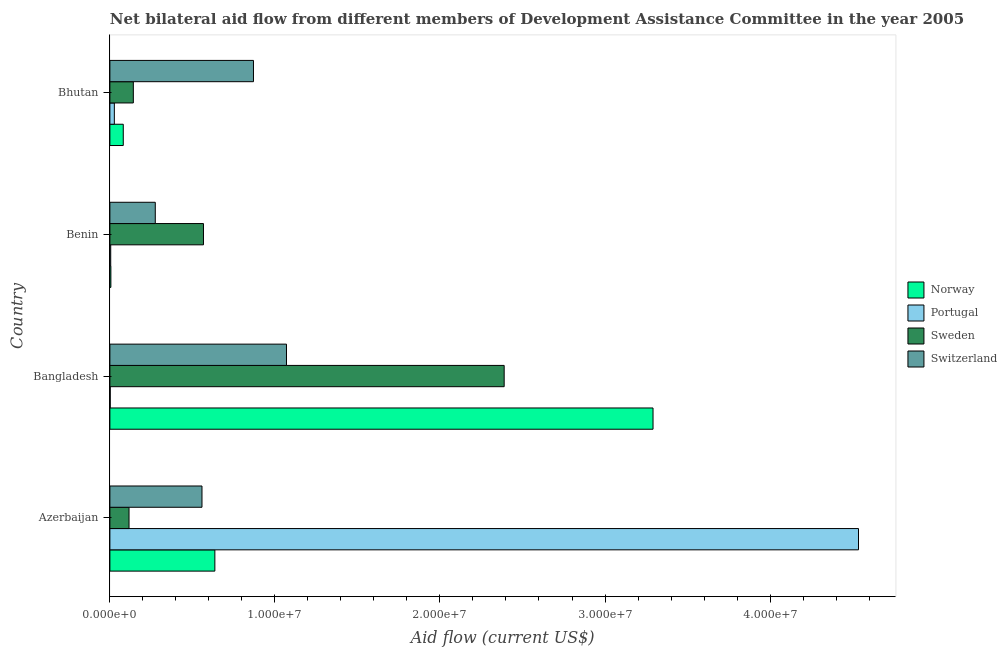How many different coloured bars are there?
Keep it short and to the point. 4. Are the number of bars on each tick of the Y-axis equal?
Make the answer very short. Yes. What is the label of the 4th group of bars from the top?
Give a very brief answer. Azerbaijan. In how many cases, is the number of bars for a given country not equal to the number of legend labels?
Provide a succinct answer. 0. What is the amount of aid given by portugal in Benin?
Provide a succinct answer. 5.00e+04. Across all countries, what is the maximum amount of aid given by norway?
Ensure brevity in your answer.  3.29e+07. Across all countries, what is the minimum amount of aid given by portugal?
Offer a very short reply. 2.00e+04. In which country was the amount of aid given by portugal maximum?
Make the answer very short. Azerbaijan. In which country was the amount of aid given by switzerland minimum?
Provide a succinct answer. Benin. What is the total amount of aid given by switzerland in the graph?
Provide a succinct answer. 2.77e+07. What is the difference between the amount of aid given by portugal in Azerbaijan and that in Bangladesh?
Your answer should be compact. 4.53e+07. What is the difference between the amount of aid given by sweden in Bangladesh and the amount of aid given by portugal in Azerbaijan?
Provide a succinct answer. -2.15e+07. What is the average amount of aid given by portugal per country?
Offer a very short reply. 1.14e+07. What is the difference between the amount of aid given by portugal and amount of aid given by switzerland in Benin?
Make the answer very short. -2.70e+06. In how many countries, is the amount of aid given by sweden greater than 42000000 US$?
Give a very brief answer. 0. What is the ratio of the amount of aid given by switzerland in Azerbaijan to that in Benin?
Your answer should be compact. 2.03. Is the difference between the amount of aid given by portugal in Azerbaijan and Benin greater than the difference between the amount of aid given by norway in Azerbaijan and Benin?
Your answer should be very brief. Yes. What is the difference between the highest and the second highest amount of aid given by switzerland?
Give a very brief answer. 2.00e+06. What is the difference between the highest and the lowest amount of aid given by switzerland?
Keep it short and to the point. 7.95e+06. Is the sum of the amount of aid given by portugal in Azerbaijan and Benin greater than the maximum amount of aid given by switzerland across all countries?
Keep it short and to the point. Yes. What does the 1st bar from the top in Bhutan represents?
Your answer should be compact. Switzerland. Is it the case that in every country, the sum of the amount of aid given by norway and amount of aid given by portugal is greater than the amount of aid given by sweden?
Your answer should be compact. No. How many bars are there?
Provide a short and direct response. 16. Are all the bars in the graph horizontal?
Your response must be concise. Yes. Are the values on the major ticks of X-axis written in scientific E-notation?
Make the answer very short. Yes. Does the graph contain any zero values?
Provide a succinct answer. No. Where does the legend appear in the graph?
Offer a terse response. Center right. How are the legend labels stacked?
Offer a terse response. Vertical. What is the title of the graph?
Your answer should be very brief. Net bilateral aid flow from different members of Development Assistance Committee in the year 2005. What is the label or title of the Y-axis?
Provide a succinct answer. Country. What is the Aid flow (current US$) of Norway in Azerbaijan?
Provide a succinct answer. 6.36e+06. What is the Aid flow (current US$) of Portugal in Azerbaijan?
Your answer should be compact. 4.54e+07. What is the Aid flow (current US$) of Sweden in Azerbaijan?
Ensure brevity in your answer.  1.16e+06. What is the Aid flow (current US$) of Switzerland in Azerbaijan?
Ensure brevity in your answer.  5.58e+06. What is the Aid flow (current US$) of Norway in Bangladesh?
Your response must be concise. 3.29e+07. What is the Aid flow (current US$) of Portugal in Bangladesh?
Provide a short and direct response. 2.00e+04. What is the Aid flow (current US$) in Sweden in Bangladesh?
Keep it short and to the point. 2.39e+07. What is the Aid flow (current US$) in Switzerland in Bangladesh?
Make the answer very short. 1.07e+07. What is the Aid flow (current US$) of Portugal in Benin?
Provide a succinct answer. 5.00e+04. What is the Aid flow (current US$) in Sweden in Benin?
Ensure brevity in your answer.  5.67e+06. What is the Aid flow (current US$) of Switzerland in Benin?
Ensure brevity in your answer.  2.75e+06. What is the Aid flow (current US$) of Norway in Bhutan?
Provide a short and direct response. 8.10e+05. What is the Aid flow (current US$) in Sweden in Bhutan?
Your answer should be very brief. 1.42e+06. What is the Aid flow (current US$) of Switzerland in Bhutan?
Your response must be concise. 8.70e+06. Across all countries, what is the maximum Aid flow (current US$) in Norway?
Give a very brief answer. 3.29e+07. Across all countries, what is the maximum Aid flow (current US$) of Portugal?
Offer a very short reply. 4.54e+07. Across all countries, what is the maximum Aid flow (current US$) of Sweden?
Offer a terse response. 2.39e+07. Across all countries, what is the maximum Aid flow (current US$) in Switzerland?
Keep it short and to the point. 1.07e+07. Across all countries, what is the minimum Aid flow (current US$) in Sweden?
Your answer should be very brief. 1.16e+06. Across all countries, what is the minimum Aid flow (current US$) of Switzerland?
Offer a very short reply. 2.75e+06. What is the total Aid flow (current US$) in Norway in the graph?
Provide a short and direct response. 4.01e+07. What is the total Aid flow (current US$) of Portugal in the graph?
Ensure brevity in your answer.  4.57e+07. What is the total Aid flow (current US$) of Sweden in the graph?
Your answer should be very brief. 3.21e+07. What is the total Aid flow (current US$) in Switzerland in the graph?
Ensure brevity in your answer.  2.77e+07. What is the difference between the Aid flow (current US$) of Norway in Azerbaijan and that in Bangladesh?
Your answer should be compact. -2.66e+07. What is the difference between the Aid flow (current US$) in Portugal in Azerbaijan and that in Bangladesh?
Your response must be concise. 4.53e+07. What is the difference between the Aid flow (current US$) of Sweden in Azerbaijan and that in Bangladesh?
Your response must be concise. -2.27e+07. What is the difference between the Aid flow (current US$) in Switzerland in Azerbaijan and that in Bangladesh?
Make the answer very short. -5.12e+06. What is the difference between the Aid flow (current US$) in Norway in Azerbaijan and that in Benin?
Make the answer very short. 6.30e+06. What is the difference between the Aid flow (current US$) of Portugal in Azerbaijan and that in Benin?
Provide a succinct answer. 4.53e+07. What is the difference between the Aid flow (current US$) in Sweden in Azerbaijan and that in Benin?
Ensure brevity in your answer.  -4.51e+06. What is the difference between the Aid flow (current US$) in Switzerland in Azerbaijan and that in Benin?
Provide a succinct answer. 2.83e+06. What is the difference between the Aid flow (current US$) in Norway in Azerbaijan and that in Bhutan?
Keep it short and to the point. 5.55e+06. What is the difference between the Aid flow (current US$) of Portugal in Azerbaijan and that in Bhutan?
Give a very brief answer. 4.51e+07. What is the difference between the Aid flow (current US$) of Switzerland in Azerbaijan and that in Bhutan?
Offer a terse response. -3.12e+06. What is the difference between the Aid flow (current US$) of Norway in Bangladesh and that in Benin?
Your answer should be compact. 3.28e+07. What is the difference between the Aid flow (current US$) in Sweden in Bangladesh and that in Benin?
Offer a terse response. 1.82e+07. What is the difference between the Aid flow (current US$) of Switzerland in Bangladesh and that in Benin?
Offer a very short reply. 7.95e+06. What is the difference between the Aid flow (current US$) of Norway in Bangladesh and that in Bhutan?
Offer a terse response. 3.21e+07. What is the difference between the Aid flow (current US$) in Sweden in Bangladesh and that in Bhutan?
Your response must be concise. 2.25e+07. What is the difference between the Aid flow (current US$) in Switzerland in Bangladesh and that in Bhutan?
Make the answer very short. 2.00e+06. What is the difference between the Aid flow (current US$) in Norway in Benin and that in Bhutan?
Your answer should be compact. -7.50e+05. What is the difference between the Aid flow (current US$) in Portugal in Benin and that in Bhutan?
Ensure brevity in your answer.  -2.20e+05. What is the difference between the Aid flow (current US$) in Sweden in Benin and that in Bhutan?
Offer a very short reply. 4.25e+06. What is the difference between the Aid flow (current US$) of Switzerland in Benin and that in Bhutan?
Offer a terse response. -5.95e+06. What is the difference between the Aid flow (current US$) in Norway in Azerbaijan and the Aid flow (current US$) in Portugal in Bangladesh?
Provide a short and direct response. 6.34e+06. What is the difference between the Aid flow (current US$) of Norway in Azerbaijan and the Aid flow (current US$) of Sweden in Bangladesh?
Ensure brevity in your answer.  -1.75e+07. What is the difference between the Aid flow (current US$) of Norway in Azerbaijan and the Aid flow (current US$) of Switzerland in Bangladesh?
Provide a succinct answer. -4.34e+06. What is the difference between the Aid flow (current US$) in Portugal in Azerbaijan and the Aid flow (current US$) in Sweden in Bangladesh?
Your answer should be compact. 2.15e+07. What is the difference between the Aid flow (current US$) in Portugal in Azerbaijan and the Aid flow (current US$) in Switzerland in Bangladesh?
Keep it short and to the point. 3.47e+07. What is the difference between the Aid flow (current US$) in Sweden in Azerbaijan and the Aid flow (current US$) in Switzerland in Bangladesh?
Your answer should be compact. -9.54e+06. What is the difference between the Aid flow (current US$) of Norway in Azerbaijan and the Aid flow (current US$) of Portugal in Benin?
Provide a succinct answer. 6.31e+06. What is the difference between the Aid flow (current US$) of Norway in Azerbaijan and the Aid flow (current US$) of Sweden in Benin?
Ensure brevity in your answer.  6.90e+05. What is the difference between the Aid flow (current US$) of Norway in Azerbaijan and the Aid flow (current US$) of Switzerland in Benin?
Keep it short and to the point. 3.61e+06. What is the difference between the Aid flow (current US$) of Portugal in Azerbaijan and the Aid flow (current US$) of Sweden in Benin?
Your answer should be very brief. 3.97e+07. What is the difference between the Aid flow (current US$) in Portugal in Azerbaijan and the Aid flow (current US$) in Switzerland in Benin?
Ensure brevity in your answer.  4.26e+07. What is the difference between the Aid flow (current US$) in Sweden in Azerbaijan and the Aid flow (current US$) in Switzerland in Benin?
Offer a terse response. -1.59e+06. What is the difference between the Aid flow (current US$) of Norway in Azerbaijan and the Aid flow (current US$) of Portugal in Bhutan?
Provide a short and direct response. 6.09e+06. What is the difference between the Aid flow (current US$) in Norway in Azerbaijan and the Aid flow (current US$) in Sweden in Bhutan?
Your answer should be compact. 4.94e+06. What is the difference between the Aid flow (current US$) of Norway in Azerbaijan and the Aid flow (current US$) of Switzerland in Bhutan?
Your answer should be compact. -2.34e+06. What is the difference between the Aid flow (current US$) of Portugal in Azerbaijan and the Aid flow (current US$) of Sweden in Bhutan?
Provide a short and direct response. 4.39e+07. What is the difference between the Aid flow (current US$) in Portugal in Azerbaijan and the Aid flow (current US$) in Switzerland in Bhutan?
Keep it short and to the point. 3.67e+07. What is the difference between the Aid flow (current US$) in Sweden in Azerbaijan and the Aid flow (current US$) in Switzerland in Bhutan?
Give a very brief answer. -7.54e+06. What is the difference between the Aid flow (current US$) in Norway in Bangladesh and the Aid flow (current US$) in Portugal in Benin?
Your answer should be very brief. 3.29e+07. What is the difference between the Aid flow (current US$) of Norway in Bangladesh and the Aid flow (current US$) of Sweden in Benin?
Provide a succinct answer. 2.72e+07. What is the difference between the Aid flow (current US$) in Norway in Bangladesh and the Aid flow (current US$) in Switzerland in Benin?
Provide a short and direct response. 3.02e+07. What is the difference between the Aid flow (current US$) of Portugal in Bangladesh and the Aid flow (current US$) of Sweden in Benin?
Make the answer very short. -5.65e+06. What is the difference between the Aid flow (current US$) of Portugal in Bangladesh and the Aid flow (current US$) of Switzerland in Benin?
Offer a very short reply. -2.73e+06. What is the difference between the Aid flow (current US$) of Sweden in Bangladesh and the Aid flow (current US$) of Switzerland in Benin?
Provide a short and direct response. 2.11e+07. What is the difference between the Aid flow (current US$) in Norway in Bangladesh and the Aid flow (current US$) in Portugal in Bhutan?
Provide a succinct answer. 3.26e+07. What is the difference between the Aid flow (current US$) in Norway in Bangladesh and the Aid flow (current US$) in Sweden in Bhutan?
Offer a terse response. 3.15e+07. What is the difference between the Aid flow (current US$) of Norway in Bangladesh and the Aid flow (current US$) of Switzerland in Bhutan?
Your answer should be compact. 2.42e+07. What is the difference between the Aid flow (current US$) of Portugal in Bangladesh and the Aid flow (current US$) of Sweden in Bhutan?
Ensure brevity in your answer.  -1.40e+06. What is the difference between the Aid flow (current US$) in Portugal in Bangladesh and the Aid flow (current US$) in Switzerland in Bhutan?
Your answer should be compact. -8.68e+06. What is the difference between the Aid flow (current US$) of Sweden in Bangladesh and the Aid flow (current US$) of Switzerland in Bhutan?
Keep it short and to the point. 1.52e+07. What is the difference between the Aid flow (current US$) of Norway in Benin and the Aid flow (current US$) of Sweden in Bhutan?
Provide a succinct answer. -1.36e+06. What is the difference between the Aid flow (current US$) in Norway in Benin and the Aid flow (current US$) in Switzerland in Bhutan?
Keep it short and to the point. -8.64e+06. What is the difference between the Aid flow (current US$) in Portugal in Benin and the Aid flow (current US$) in Sweden in Bhutan?
Offer a terse response. -1.37e+06. What is the difference between the Aid flow (current US$) of Portugal in Benin and the Aid flow (current US$) of Switzerland in Bhutan?
Ensure brevity in your answer.  -8.65e+06. What is the difference between the Aid flow (current US$) of Sweden in Benin and the Aid flow (current US$) of Switzerland in Bhutan?
Make the answer very short. -3.03e+06. What is the average Aid flow (current US$) of Norway per country?
Offer a terse response. 1.00e+07. What is the average Aid flow (current US$) in Portugal per country?
Your response must be concise. 1.14e+07. What is the average Aid flow (current US$) in Sweden per country?
Ensure brevity in your answer.  8.04e+06. What is the average Aid flow (current US$) of Switzerland per country?
Provide a succinct answer. 6.93e+06. What is the difference between the Aid flow (current US$) of Norway and Aid flow (current US$) of Portugal in Azerbaijan?
Provide a succinct answer. -3.90e+07. What is the difference between the Aid flow (current US$) in Norway and Aid flow (current US$) in Sweden in Azerbaijan?
Your answer should be very brief. 5.20e+06. What is the difference between the Aid flow (current US$) in Norway and Aid flow (current US$) in Switzerland in Azerbaijan?
Offer a terse response. 7.80e+05. What is the difference between the Aid flow (current US$) of Portugal and Aid flow (current US$) of Sweden in Azerbaijan?
Offer a very short reply. 4.42e+07. What is the difference between the Aid flow (current US$) in Portugal and Aid flow (current US$) in Switzerland in Azerbaijan?
Ensure brevity in your answer.  3.98e+07. What is the difference between the Aid flow (current US$) of Sweden and Aid flow (current US$) of Switzerland in Azerbaijan?
Offer a very short reply. -4.42e+06. What is the difference between the Aid flow (current US$) in Norway and Aid flow (current US$) in Portugal in Bangladesh?
Give a very brief answer. 3.29e+07. What is the difference between the Aid flow (current US$) of Norway and Aid flow (current US$) of Sweden in Bangladesh?
Your answer should be very brief. 9.02e+06. What is the difference between the Aid flow (current US$) of Norway and Aid flow (current US$) of Switzerland in Bangladesh?
Make the answer very short. 2.22e+07. What is the difference between the Aid flow (current US$) of Portugal and Aid flow (current US$) of Sweden in Bangladesh?
Provide a short and direct response. -2.39e+07. What is the difference between the Aid flow (current US$) of Portugal and Aid flow (current US$) of Switzerland in Bangladesh?
Your response must be concise. -1.07e+07. What is the difference between the Aid flow (current US$) of Sweden and Aid flow (current US$) of Switzerland in Bangladesh?
Give a very brief answer. 1.32e+07. What is the difference between the Aid flow (current US$) in Norway and Aid flow (current US$) in Portugal in Benin?
Ensure brevity in your answer.  10000. What is the difference between the Aid flow (current US$) in Norway and Aid flow (current US$) in Sweden in Benin?
Your answer should be compact. -5.61e+06. What is the difference between the Aid flow (current US$) in Norway and Aid flow (current US$) in Switzerland in Benin?
Your response must be concise. -2.69e+06. What is the difference between the Aid flow (current US$) in Portugal and Aid flow (current US$) in Sweden in Benin?
Provide a short and direct response. -5.62e+06. What is the difference between the Aid flow (current US$) in Portugal and Aid flow (current US$) in Switzerland in Benin?
Your answer should be very brief. -2.70e+06. What is the difference between the Aid flow (current US$) of Sweden and Aid flow (current US$) of Switzerland in Benin?
Make the answer very short. 2.92e+06. What is the difference between the Aid flow (current US$) of Norway and Aid flow (current US$) of Portugal in Bhutan?
Your response must be concise. 5.40e+05. What is the difference between the Aid flow (current US$) of Norway and Aid flow (current US$) of Sweden in Bhutan?
Ensure brevity in your answer.  -6.10e+05. What is the difference between the Aid flow (current US$) in Norway and Aid flow (current US$) in Switzerland in Bhutan?
Your answer should be compact. -7.89e+06. What is the difference between the Aid flow (current US$) in Portugal and Aid flow (current US$) in Sweden in Bhutan?
Ensure brevity in your answer.  -1.15e+06. What is the difference between the Aid flow (current US$) of Portugal and Aid flow (current US$) of Switzerland in Bhutan?
Ensure brevity in your answer.  -8.43e+06. What is the difference between the Aid flow (current US$) in Sweden and Aid flow (current US$) in Switzerland in Bhutan?
Your response must be concise. -7.28e+06. What is the ratio of the Aid flow (current US$) of Norway in Azerbaijan to that in Bangladesh?
Provide a succinct answer. 0.19. What is the ratio of the Aid flow (current US$) of Portugal in Azerbaijan to that in Bangladesh?
Your answer should be very brief. 2268. What is the ratio of the Aid flow (current US$) in Sweden in Azerbaijan to that in Bangladesh?
Provide a short and direct response. 0.05. What is the ratio of the Aid flow (current US$) in Switzerland in Azerbaijan to that in Bangladesh?
Offer a very short reply. 0.52. What is the ratio of the Aid flow (current US$) in Norway in Azerbaijan to that in Benin?
Make the answer very short. 106. What is the ratio of the Aid flow (current US$) of Portugal in Azerbaijan to that in Benin?
Provide a succinct answer. 907.2. What is the ratio of the Aid flow (current US$) of Sweden in Azerbaijan to that in Benin?
Your answer should be compact. 0.2. What is the ratio of the Aid flow (current US$) of Switzerland in Azerbaijan to that in Benin?
Ensure brevity in your answer.  2.03. What is the ratio of the Aid flow (current US$) of Norway in Azerbaijan to that in Bhutan?
Your response must be concise. 7.85. What is the ratio of the Aid flow (current US$) of Portugal in Azerbaijan to that in Bhutan?
Provide a succinct answer. 168. What is the ratio of the Aid flow (current US$) in Sweden in Azerbaijan to that in Bhutan?
Your response must be concise. 0.82. What is the ratio of the Aid flow (current US$) of Switzerland in Azerbaijan to that in Bhutan?
Ensure brevity in your answer.  0.64. What is the ratio of the Aid flow (current US$) of Norway in Bangladesh to that in Benin?
Ensure brevity in your answer.  548.5. What is the ratio of the Aid flow (current US$) in Portugal in Bangladesh to that in Benin?
Your answer should be compact. 0.4. What is the ratio of the Aid flow (current US$) of Sweden in Bangladesh to that in Benin?
Provide a short and direct response. 4.21. What is the ratio of the Aid flow (current US$) in Switzerland in Bangladesh to that in Benin?
Give a very brief answer. 3.89. What is the ratio of the Aid flow (current US$) in Norway in Bangladesh to that in Bhutan?
Your response must be concise. 40.63. What is the ratio of the Aid flow (current US$) in Portugal in Bangladesh to that in Bhutan?
Your answer should be very brief. 0.07. What is the ratio of the Aid flow (current US$) in Sweden in Bangladesh to that in Bhutan?
Give a very brief answer. 16.82. What is the ratio of the Aid flow (current US$) in Switzerland in Bangladesh to that in Bhutan?
Offer a very short reply. 1.23. What is the ratio of the Aid flow (current US$) of Norway in Benin to that in Bhutan?
Provide a short and direct response. 0.07. What is the ratio of the Aid flow (current US$) in Portugal in Benin to that in Bhutan?
Your response must be concise. 0.19. What is the ratio of the Aid flow (current US$) in Sweden in Benin to that in Bhutan?
Your answer should be compact. 3.99. What is the ratio of the Aid flow (current US$) in Switzerland in Benin to that in Bhutan?
Provide a succinct answer. 0.32. What is the difference between the highest and the second highest Aid flow (current US$) of Norway?
Your answer should be compact. 2.66e+07. What is the difference between the highest and the second highest Aid flow (current US$) in Portugal?
Give a very brief answer. 4.51e+07. What is the difference between the highest and the second highest Aid flow (current US$) in Sweden?
Your response must be concise. 1.82e+07. What is the difference between the highest and the lowest Aid flow (current US$) in Norway?
Provide a short and direct response. 3.28e+07. What is the difference between the highest and the lowest Aid flow (current US$) of Portugal?
Your answer should be compact. 4.53e+07. What is the difference between the highest and the lowest Aid flow (current US$) in Sweden?
Provide a short and direct response. 2.27e+07. What is the difference between the highest and the lowest Aid flow (current US$) of Switzerland?
Ensure brevity in your answer.  7.95e+06. 